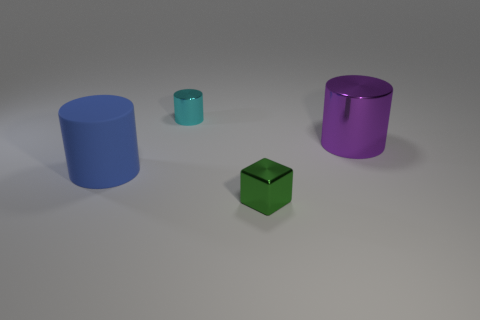Can you infer anything about the lighting in this scene? The lighting in the scene seems to be coming from above, as indicated by the shadows cast directly underneath the objects. The light source doesn't appear to be too harsh, given the softness of the shadows, suggesting a diffuse light probably in a studio setting meant for highlighting the objects without creating strong contrasts. 